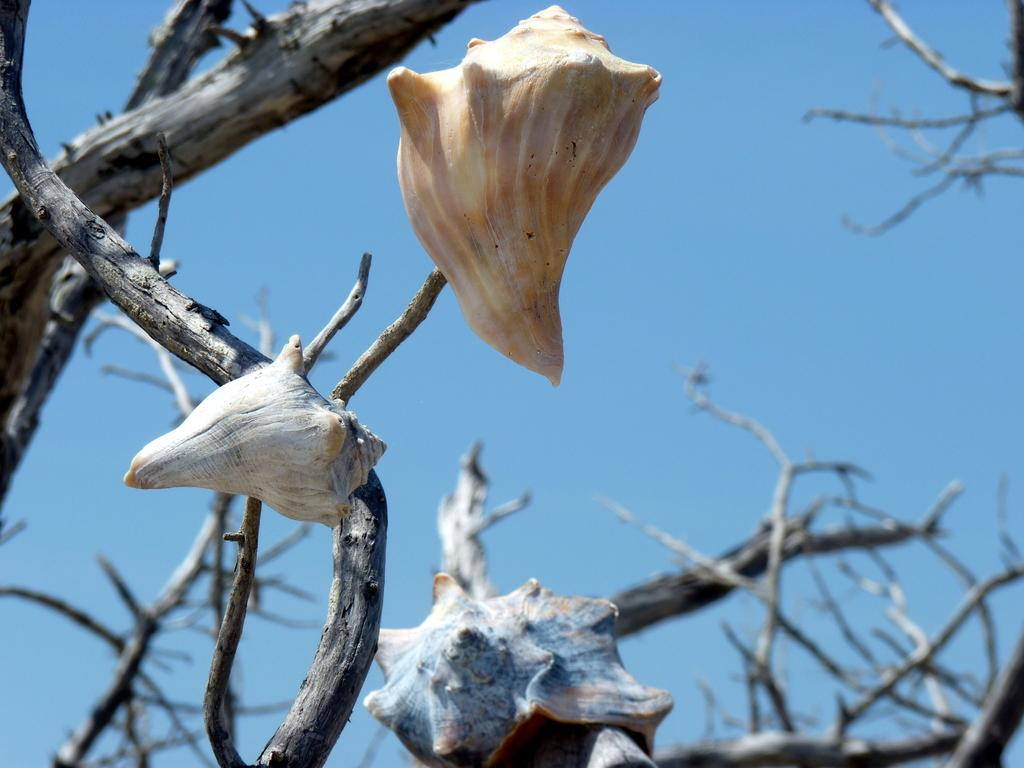Where was the picture taken? The picture was clicked outside. What can be seen hanging on the branches of a tree in the foreground? There are objects hanging on the branches of a tree in the foreground. What is visible in the background of the image? There is a sky visible in the background. What else can be seen in the background besides the sky? There are stems present in the background. Where is the shelf located in the image? There is no shelf present in the image. What type of bulb can be seen illuminating the objects hanging on the tree branches? There is no bulb present in the image; the objects are hanging on the tree branches in daylight. 